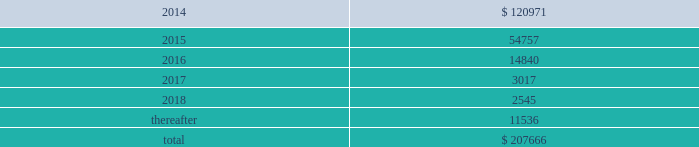Interest expense related to capital lease obligations was $ 1.7 million during both the years ended december 31 , 2013 and 2012 , and $ 1.5 million during the year ended december 31 , 2011 .
Purchase commitments in the table below , we set forth our enforceable and legally binding purchase obligations as of december 31 , 2013 .
Some of the amounts included in the table are based on management 2019s estimates and assumptions about these obligations , including their duration , the possibility of renewal , anticipated actions by third parties , and other factors .
Because these estimates and assumptions are necessarily subjective , our actual payments may vary from those reflected in the table .
Purchase orders made in the ordinary course of business are excluded from the table below .
Any amounts for which we are liable under purchase orders are reflected on the consolidated balance sheets as accounts payable and accrued liabilities .
These obligations relate to various purchase agreements for items such as minimum amounts of fiber and energy purchases over periods ranging from one to 15 years .
Total purchase commitments are as follows ( dollars in thousands ) : .
The company purchased a total of $ 61.7 million , $ 27.7 million , and $ 28.5 million during the years ended december 31 , 2013 , 2012 , and 2011 , respectively , under these purchase agreements .
The increase in purchase commitments in 2014 , compared with 2013 , relates to the acquisition of boise in fourth quarter 2013 .
Environmental liabilities the potential costs for various environmental matters are uncertain due to such factors as the unknown magnitude of possible cleanup costs , the complexity and evolving nature of governmental laws and regulations and their interpretations , and the timing , varying costs and effectiveness of alternative cleanup technologies .
From 1994 through 2013 , remediation costs at the company 2019s mills and corrugated plants totaled approximately $ 3.2 million .
At december 31 , 2013 , the company had $ 34.1 million of environmental-related reserves recorded on its consolidated balance sheet .
Of the $ 34.1 million , approximately $ 26.5 million related to environmental- related asset retirement obligations discussed in note 14 , asset retirement obligations , and $ 7.6 million related to our estimate of other environmental contingencies .
The company recorded $ 7.8 million in 201caccrued liabilities 201d and $ 26.3 million in 201cother long-term liabilities 201d on the consolidated balance sheet .
Liabilities recorded for environmental contingencies are estimates of the probable costs based upon available information and assumptions .
Because of these uncertainties , pca 2019s estimates may change .
As of the date of this filing , the company believes that it is not reasonably possible that future environmental expenditures for remediation costs and asset retirement obligations above the $ 34.1 million accrued as of december 31 , 2013 , will have a material impact on its financial condition , results of operations , or cash flows .
Guarantees and indemnifications we provide guarantees , indemnifications , and other assurances to third parties in the normal course of our business .
These include tort indemnifications , environmental assurances , and representations and warranties in commercial agreements .
At december 31 , 2013 , we are not aware of any material liabilities arising from any guarantee , indemnification , or financial assurance we have provided .
If we determined such a liability was probable and subject to reasonable determination , we would accrue for it at that time. .
What percentage of total purchase commitments are due in 2016? 
Computations: (14840 / 207666)
Answer: 0.07146. 